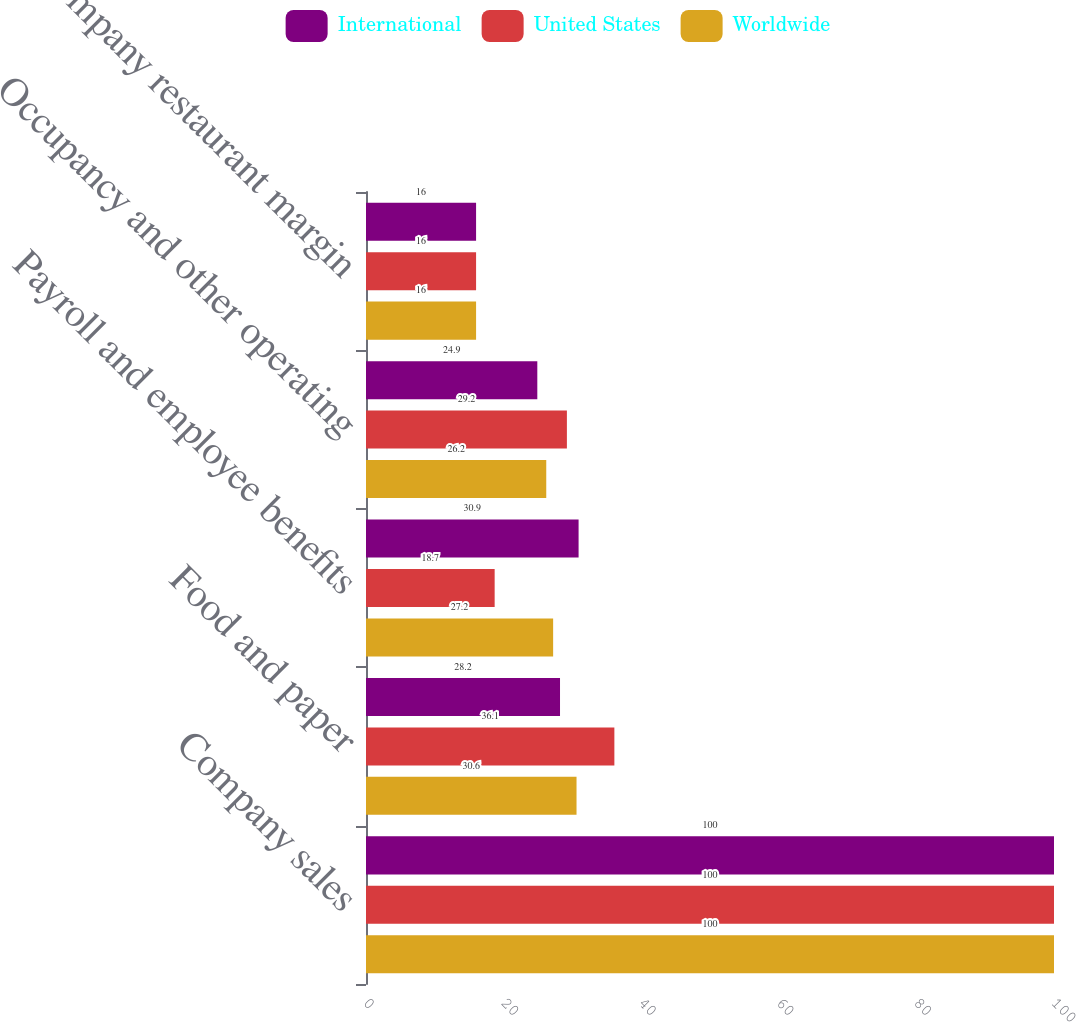Convert chart. <chart><loc_0><loc_0><loc_500><loc_500><stacked_bar_chart><ecel><fcel>Company sales<fcel>Food and paper<fcel>Payroll and employee benefits<fcel>Occupancy and other operating<fcel>Company restaurant margin<nl><fcel>International<fcel>100<fcel>28.2<fcel>30.9<fcel>24.9<fcel>16<nl><fcel>United States<fcel>100<fcel>36.1<fcel>18.7<fcel>29.2<fcel>16<nl><fcel>Worldwide<fcel>100<fcel>30.6<fcel>27.2<fcel>26.2<fcel>16<nl></chart> 